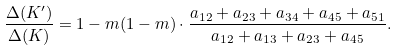Convert formula to latex. <formula><loc_0><loc_0><loc_500><loc_500>\frac { \Delta ( K ^ { \prime } ) } { \Delta ( K ) } = 1 - m ( 1 - m ) \cdot \frac { a _ { 1 2 } + a _ { 2 3 } + a _ { 3 4 } + a _ { 4 5 } + a _ { 5 1 } } { a _ { 1 2 } + a _ { 1 3 } + a _ { 2 3 } + a _ { 4 5 } } .</formula> 